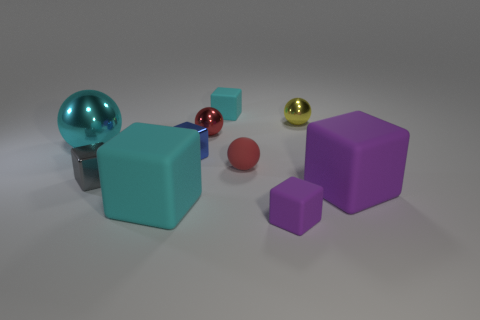There is a small shiny block that is to the right of the gray metallic block; what color is it?
Give a very brief answer. Blue. There is another small shiny thing that is the same shape as the small gray thing; what is its color?
Your answer should be compact. Blue. There is a big rubber block in front of the large matte cube right of the blue metallic block; what number of objects are in front of it?
Offer a very short reply. 1. Are there fewer tiny gray metal things in front of the gray metal cube than small cubes?
Give a very brief answer. Yes. What is the size of the blue object that is the same shape as the gray shiny object?
Provide a succinct answer. Small. What number of cyan objects are the same material as the big cyan cube?
Give a very brief answer. 1. Do the red thing behind the large cyan shiny object and the big purple thing have the same material?
Provide a short and direct response. No. Are there the same number of tiny cyan rubber objects that are in front of the tiny cyan matte thing and brown balls?
Offer a very short reply. Yes. The gray shiny block has what size?
Your answer should be very brief. Small. What material is the large object that is the same color as the large ball?
Your answer should be very brief. Rubber. 